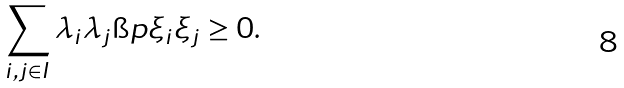<formula> <loc_0><loc_0><loc_500><loc_500>\sum _ { i , j \in I } \lambda _ { i } \lambda _ { j } \i p { \xi _ { i } } { \xi _ { j } } \geq 0 .</formula> 